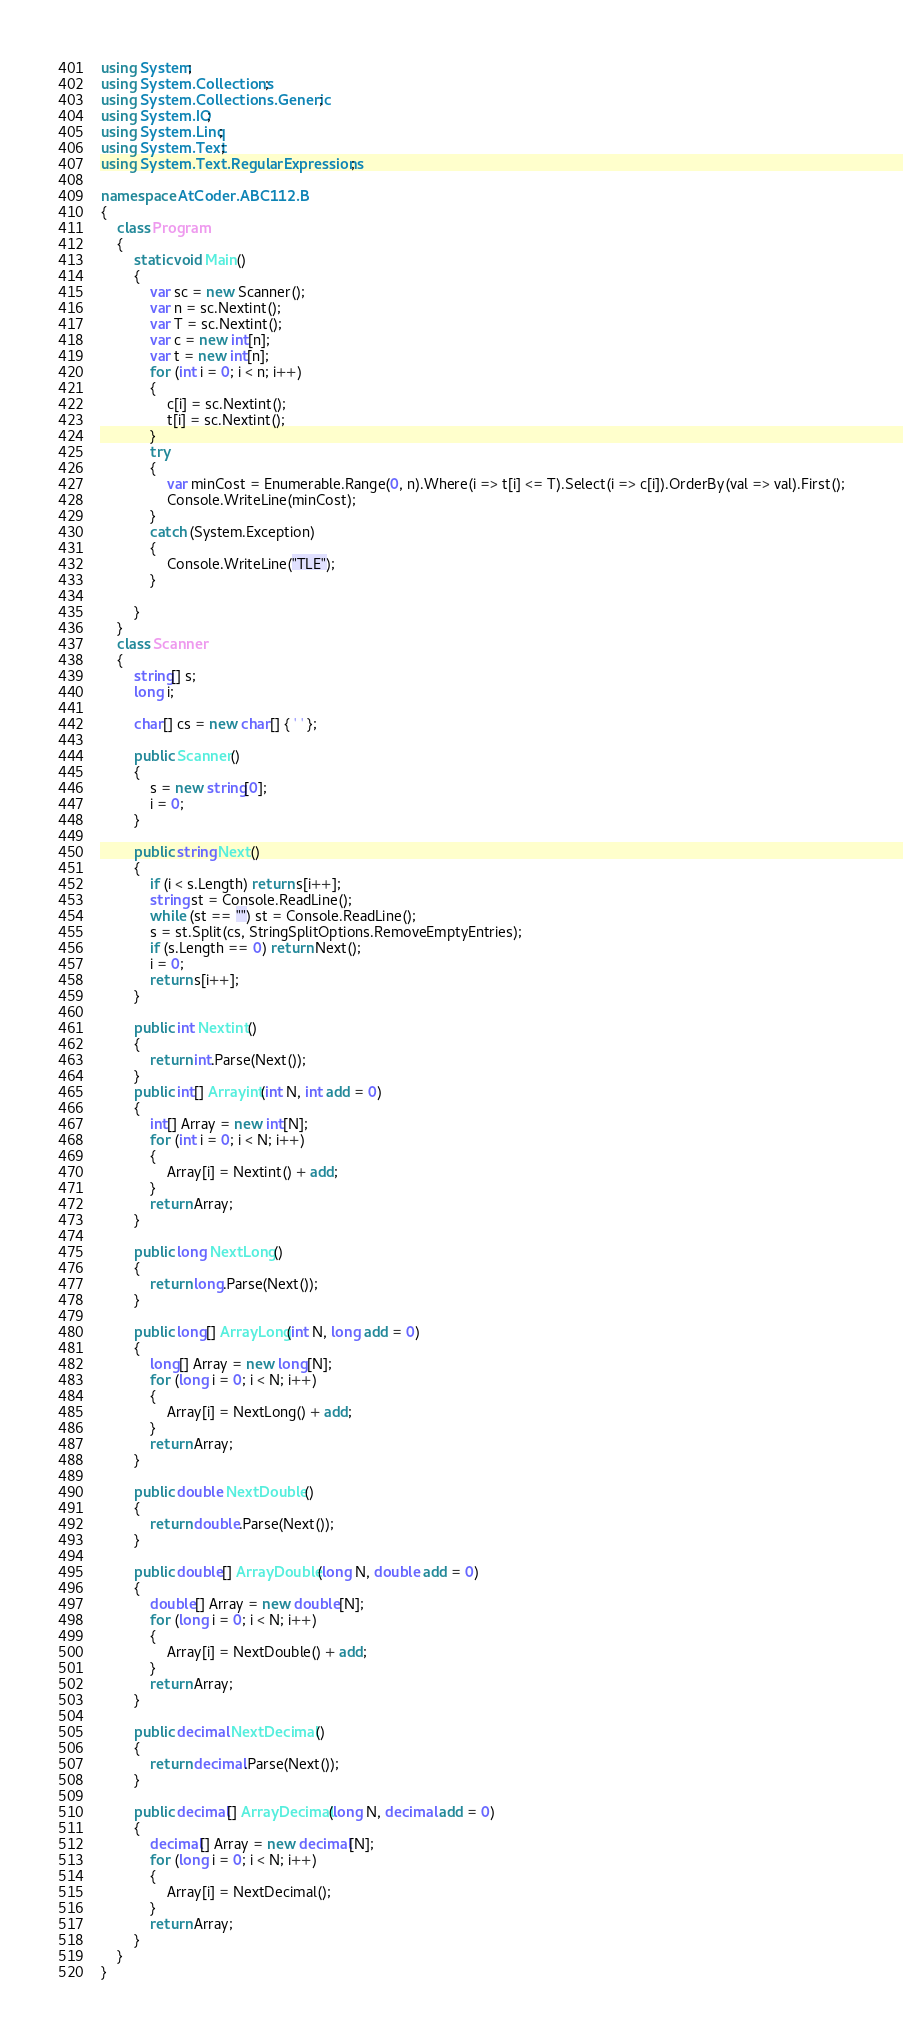<code> <loc_0><loc_0><loc_500><loc_500><_C#_>using System;
using System.Collections;
using System.Collections.Generic;
using System.IO;
using System.Linq;
using System.Text;
using System.Text.RegularExpressions;

namespace AtCoder.ABC112.B
{
    class Program
    {
        static void Main()
        {
            var sc = new Scanner();
            var n = sc.Nextint();
            var T = sc.Nextint();
            var c = new int[n];
            var t = new int[n];
            for (int i = 0; i < n; i++)
            {
                c[i] = sc.Nextint();
                t[i] = sc.Nextint();
            }
            try
            {
                var minCost = Enumerable.Range(0, n).Where(i => t[i] <= T).Select(i => c[i]).OrderBy(val => val).First();
                Console.WriteLine(minCost);
            }
            catch (System.Exception)
            {
                Console.WriteLine("TLE");
            }

        }
    }
    class Scanner
    {
        string[] s;
        long i;

        char[] cs = new char[] { ' ' };

        public Scanner()
        {
            s = new string[0];
            i = 0;
        }

        public string Next()
        {
            if (i < s.Length) return s[i++];
            string st = Console.ReadLine();
            while (st == "") st = Console.ReadLine();
            s = st.Split(cs, StringSplitOptions.RemoveEmptyEntries);
            if (s.Length == 0) return Next();
            i = 0;
            return s[i++];
        }

        public int Nextint()
        {
            return int.Parse(Next());
        }
        public int[] Arrayint(int N, int add = 0)
        {
            int[] Array = new int[N];
            for (int i = 0; i < N; i++)
            {
                Array[i] = Nextint() + add;
            }
            return Array;
        }

        public long NextLong()
        {
            return long.Parse(Next());
        }

        public long[] ArrayLong(int N, long add = 0)
        {
            long[] Array = new long[N];
            for (long i = 0; i < N; i++)
            {
                Array[i] = NextLong() + add;
            }
            return Array;
        }

        public double NextDouble()
        {
            return double.Parse(Next());
        }

        public double[] ArrayDouble(long N, double add = 0)
        {
            double[] Array = new double[N];
            for (long i = 0; i < N; i++)
            {
                Array[i] = NextDouble() + add;
            }
            return Array;
        }

        public decimal NextDecimal()
        {
            return decimal.Parse(Next());
        }

        public decimal[] ArrayDecimal(long N, decimal add = 0)
        {
            decimal[] Array = new decimal[N];
            for (long i = 0; i < N; i++)
            {
                Array[i] = NextDecimal();
            }
            return Array;
        }
    }
}</code> 